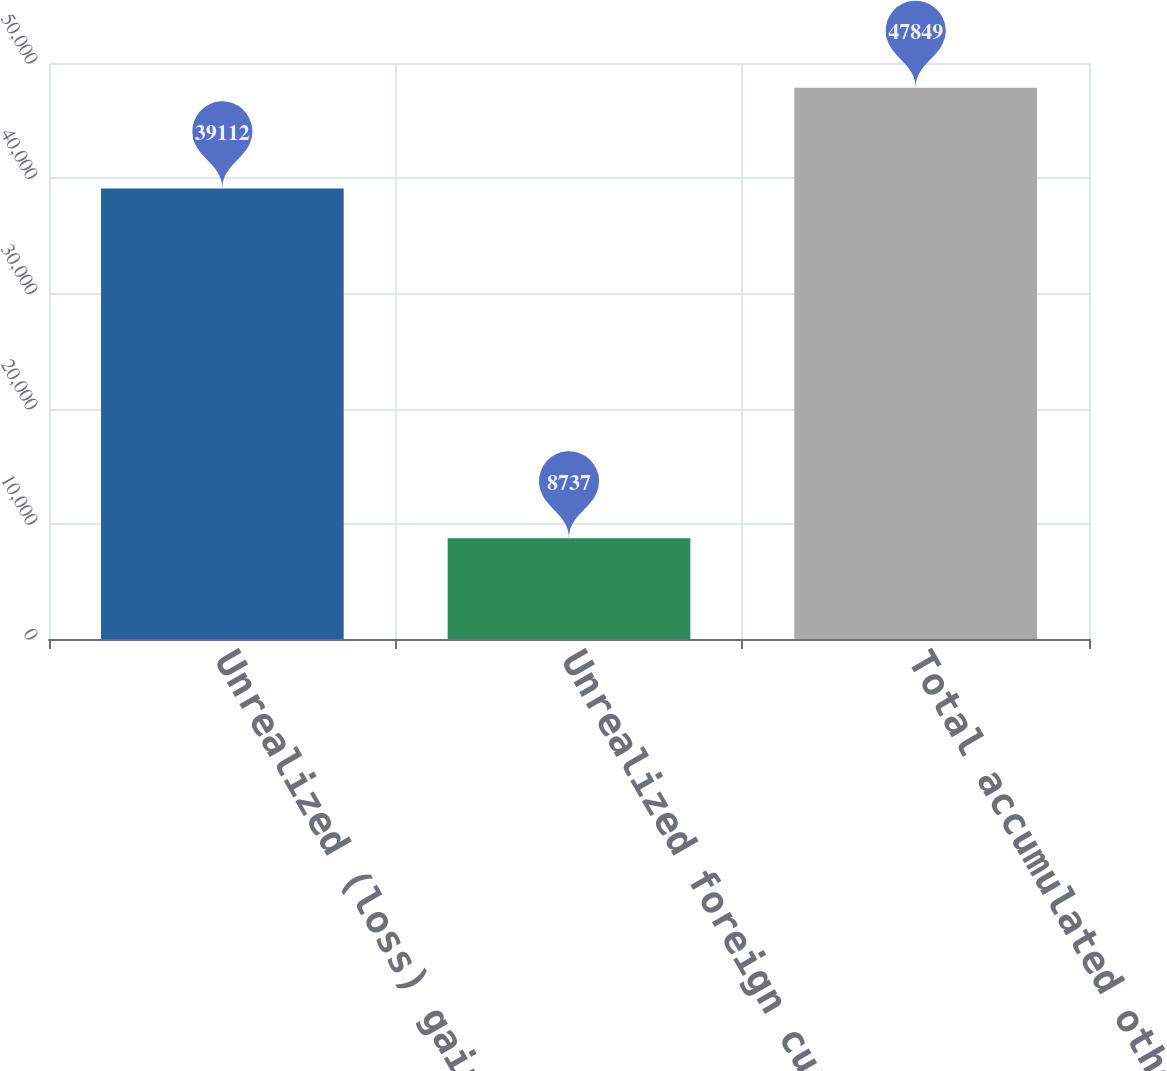Convert chart. <chart><loc_0><loc_0><loc_500><loc_500><bar_chart><fcel>Unrealized (loss) gain on<fcel>Unrealized foreign currency<fcel>Total accumulated other<nl><fcel>39112<fcel>8737<fcel>47849<nl></chart> 